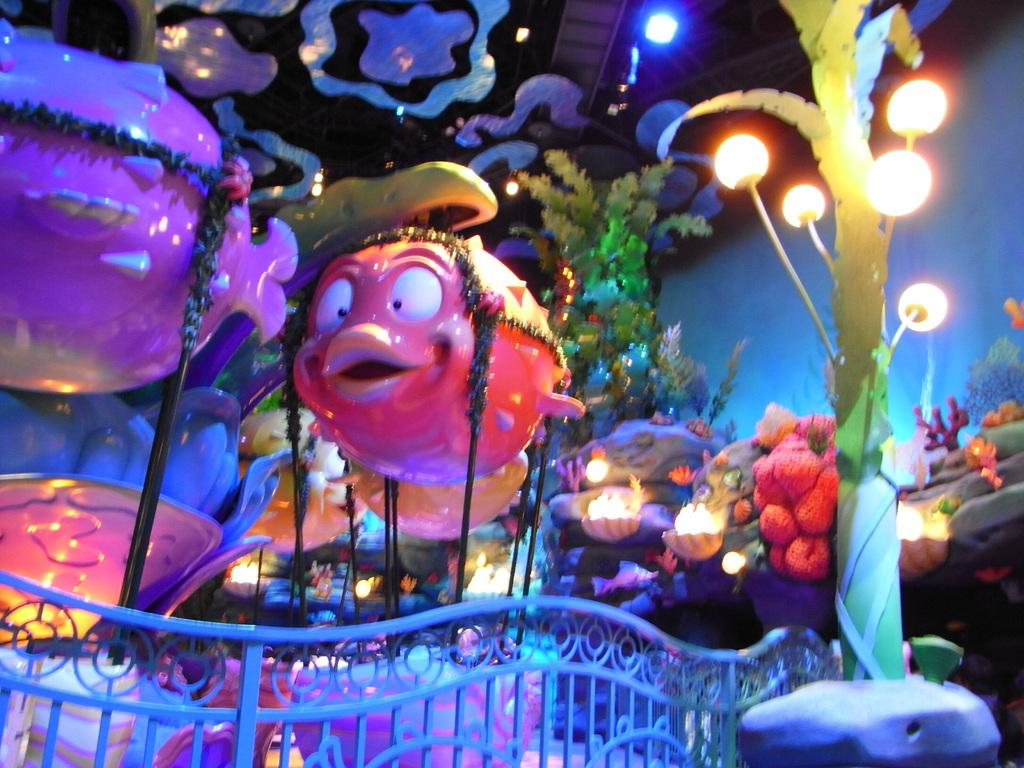What is the main subject of the image? There is a ride in the image. What can be seen in addition to the ride? There are lights, a pole, railing, plants, and unspecified objects in the image. Can you describe the lights in the image? The lights are not described in detail, but they are present in the image. What type of vegetation is visible in the image? There are plants in the image. How many clovers are present in the image? There is no mention of clovers in the image, so it is not possible to determine their presence or quantity. 